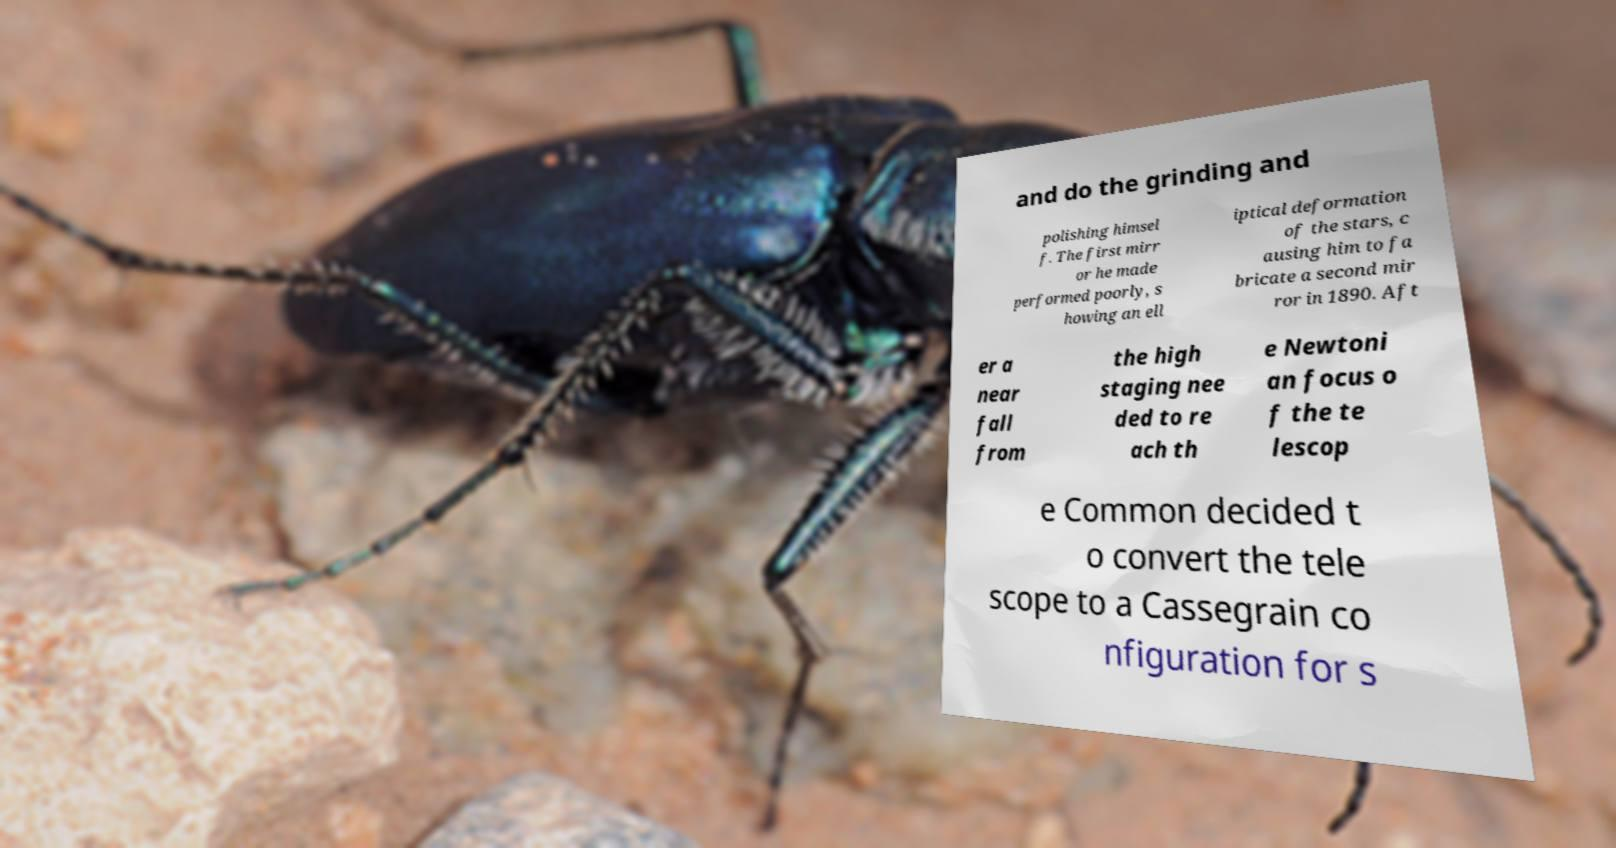Can you accurately transcribe the text from the provided image for me? and do the grinding and polishing himsel f. The first mirr or he made performed poorly, s howing an ell iptical deformation of the stars, c ausing him to fa bricate a second mir ror in 1890. Aft er a near fall from the high staging nee ded to re ach th e Newtoni an focus o f the te lescop e Common decided t o convert the tele scope to a Cassegrain co nfiguration for s 